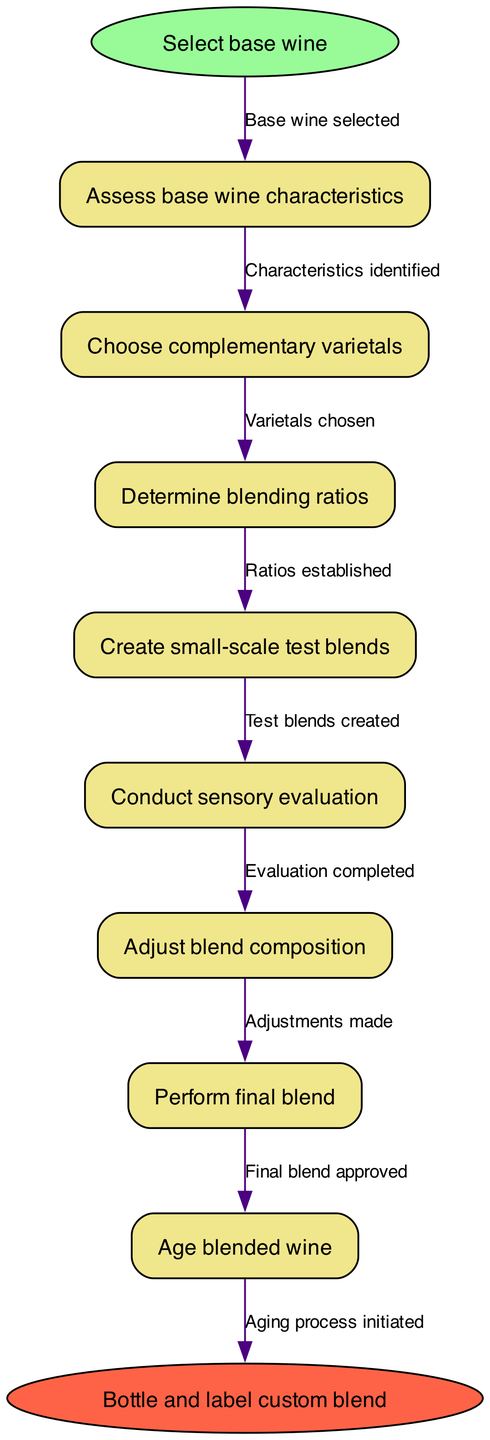What is the first step in the blending process? The first step depicted in the diagram is "Select base wine," which is identified as the start node.
Answer: Select base wine How many process nodes are there in the diagram? By counting the entries in the 'nodes' array, we see that there are a total of 8 process nodes included in the blending flowchart.
Answer: 8 What is the last step before bottling the custom blend? The final step before bottling is "Age blended wine," which is the second-to-last node leading to the endpoint.
Answer: Age blended wine What step follows "Conduct sensory evaluation"? "Adjust blend composition" comes immediately after "Conduct sensory evaluation," as indicated by the flow from one node to the next in the diagram.
Answer: Adjust blend composition How many edges connect the process nodes? Each process node connects to the next one, creating a total of 8 edges that connect the 8 nodes in the process, leading to the end node.
Answer: 8 What is the final node in the process? The final node in the process, which concludes the workflow, is "Bottle and label custom blend," identified as the endpoint in the diagram.
Answer: Bottle and label custom blend Which step requires the assessment of the base wine's characteristics? The step labeled "Assess base wine characteristics" directly follows the selection of the base wine, indicating the need to evaluate its qualities.
Answer: Assess base wine characteristics What action follows after determining blending ratios? Once "Determine blending ratios" is completed, the next step is "Create small-scale test blends," demonstrating the flow of the process.
Answer: Create small-scale test blends 